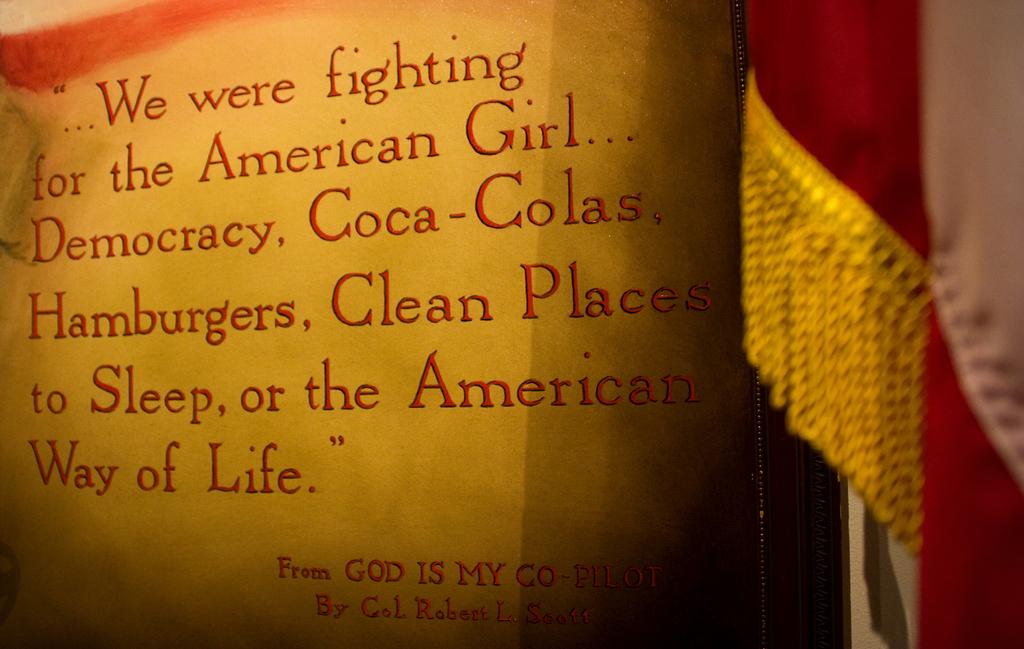Does the text include the word god ?
Offer a terse response. Yes. What are the first three words of this quote?
Provide a short and direct response. We were fighting. 